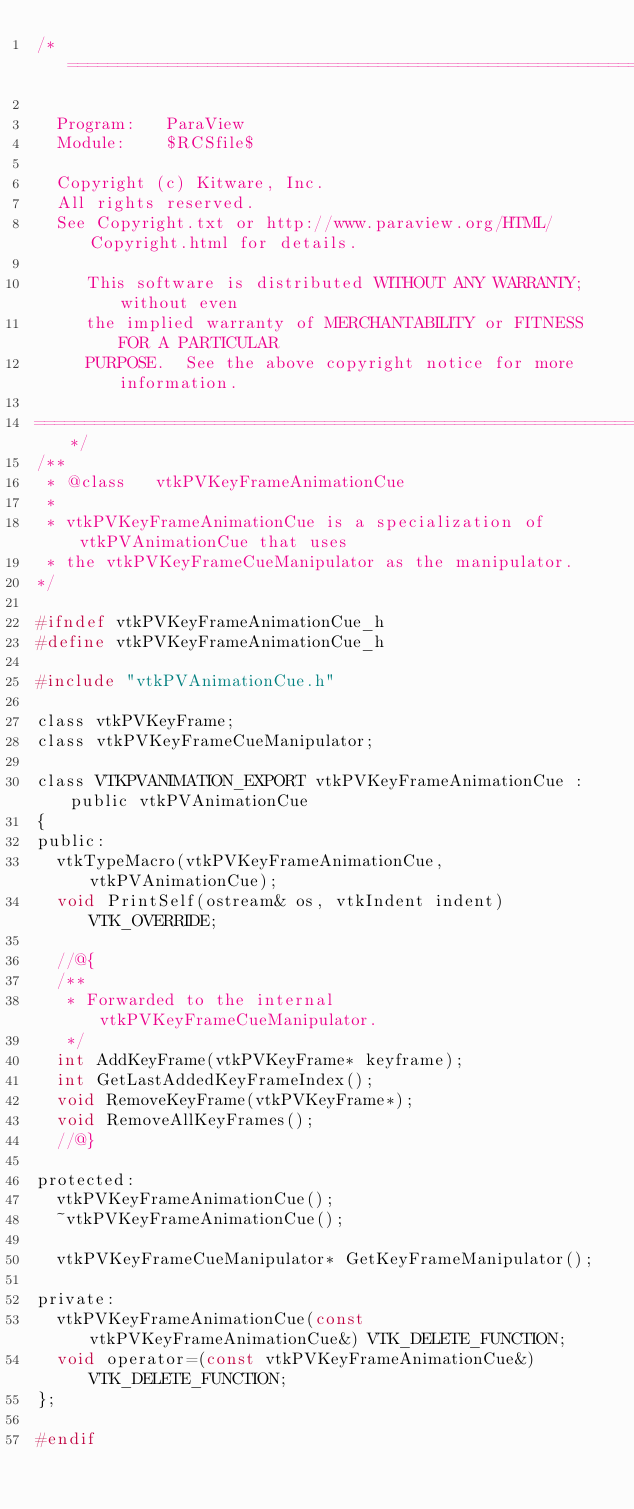Convert code to text. <code><loc_0><loc_0><loc_500><loc_500><_C_>/*=========================================================================

  Program:   ParaView
  Module:    $RCSfile$

  Copyright (c) Kitware, Inc.
  All rights reserved.
  See Copyright.txt or http://www.paraview.org/HTML/Copyright.html for details.

     This software is distributed WITHOUT ANY WARRANTY; without even
     the implied warranty of MERCHANTABILITY or FITNESS FOR A PARTICULAR
     PURPOSE.  See the above copyright notice for more information.

=========================================================================*/
/**
 * @class   vtkPVKeyFrameAnimationCue
 *
 * vtkPVKeyFrameAnimationCue is a specialization of vtkPVAnimationCue that uses
 * the vtkPVKeyFrameCueManipulator as the manipulator.
*/

#ifndef vtkPVKeyFrameAnimationCue_h
#define vtkPVKeyFrameAnimationCue_h

#include "vtkPVAnimationCue.h"

class vtkPVKeyFrame;
class vtkPVKeyFrameCueManipulator;

class VTKPVANIMATION_EXPORT vtkPVKeyFrameAnimationCue : public vtkPVAnimationCue
{
public:
  vtkTypeMacro(vtkPVKeyFrameAnimationCue, vtkPVAnimationCue);
  void PrintSelf(ostream& os, vtkIndent indent) VTK_OVERRIDE;

  //@{
  /**
   * Forwarded to the internal vtkPVKeyFrameCueManipulator.
   */
  int AddKeyFrame(vtkPVKeyFrame* keyframe);
  int GetLastAddedKeyFrameIndex();
  void RemoveKeyFrame(vtkPVKeyFrame*);
  void RemoveAllKeyFrames();
  //@}

protected:
  vtkPVKeyFrameAnimationCue();
  ~vtkPVKeyFrameAnimationCue();

  vtkPVKeyFrameCueManipulator* GetKeyFrameManipulator();

private:
  vtkPVKeyFrameAnimationCue(const vtkPVKeyFrameAnimationCue&) VTK_DELETE_FUNCTION;
  void operator=(const vtkPVKeyFrameAnimationCue&) VTK_DELETE_FUNCTION;
};

#endif
</code> 